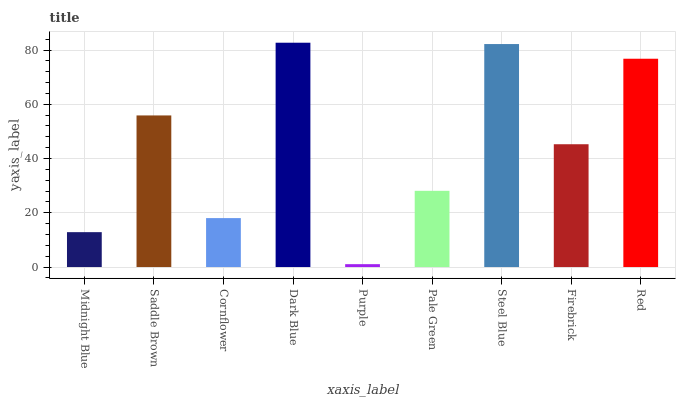Is Saddle Brown the minimum?
Answer yes or no. No. Is Saddle Brown the maximum?
Answer yes or no. No. Is Saddle Brown greater than Midnight Blue?
Answer yes or no. Yes. Is Midnight Blue less than Saddle Brown?
Answer yes or no. Yes. Is Midnight Blue greater than Saddle Brown?
Answer yes or no. No. Is Saddle Brown less than Midnight Blue?
Answer yes or no. No. Is Firebrick the high median?
Answer yes or no. Yes. Is Firebrick the low median?
Answer yes or no. Yes. Is Pale Green the high median?
Answer yes or no. No. Is Pale Green the low median?
Answer yes or no. No. 